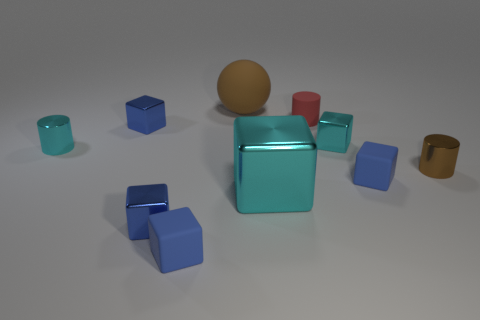There is a red thing that is the same shape as the brown metal object; what material is it?
Provide a short and direct response. Rubber. What number of metal objects are either brown cubes or cubes?
Offer a terse response. 4. Is the brown thing that is on the left side of the brown cylinder made of the same material as the blue object behind the small brown metallic thing?
Offer a very short reply. No. Is there a large green matte thing?
Keep it short and to the point. No. Is the shape of the tiny cyan metal thing behind the cyan metallic cylinder the same as the brown object on the left side of the large metallic thing?
Give a very brief answer. No. Is there a large cyan thing that has the same material as the large brown object?
Offer a terse response. No. Is the ball behind the big cyan block made of the same material as the small brown cylinder?
Offer a terse response. No. Are there more small objects to the right of the brown metal thing than tiny blue matte cubes on the left side of the brown sphere?
Make the answer very short. No. The rubber cylinder that is the same size as the brown metallic object is what color?
Provide a short and direct response. Red. Are there any large rubber balls of the same color as the large shiny block?
Keep it short and to the point. No. 